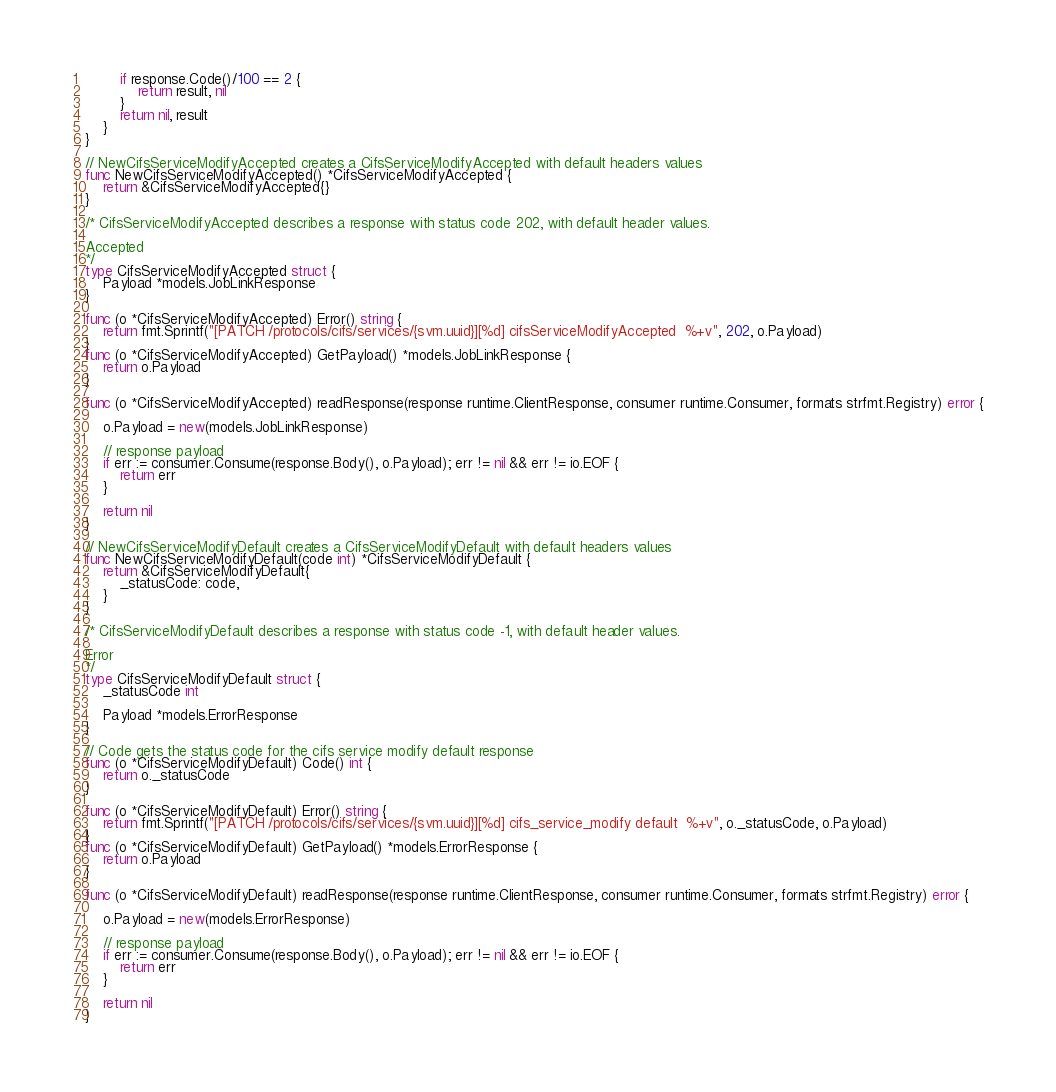Convert code to text. <code><loc_0><loc_0><loc_500><loc_500><_Go_>		if response.Code()/100 == 2 {
			return result, nil
		}
		return nil, result
	}
}

// NewCifsServiceModifyAccepted creates a CifsServiceModifyAccepted with default headers values
func NewCifsServiceModifyAccepted() *CifsServiceModifyAccepted {
	return &CifsServiceModifyAccepted{}
}

/* CifsServiceModifyAccepted describes a response with status code 202, with default header values.

Accepted
*/
type CifsServiceModifyAccepted struct {
	Payload *models.JobLinkResponse
}

func (o *CifsServiceModifyAccepted) Error() string {
	return fmt.Sprintf("[PATCH /protocols/cifs/services/{svm.uuid}][%d] cifsServiceModifyAccepted  %+v", 202, o.Payload)
}
func (o *CifsServiceModifyAccepted) GetPayload() *models.JobLinkResponse {
	return o.Payload
}

func (o *CifsServiceModifyAccepted) readResponse(response runtime.ClientResponse, consumer runtime.Consumer, formats strfmt.Registry) error {

	o.Payload = new(models.JobLinkResponse)

	// response payload
	if err := consumer.Consume(response.Body(), o.Payload); err != nil && err != io.EOF {
		return err
	}

	return nil
}

// NewCifsServiceModifyDefault creates a CifsServiceModifyDefault with default headers values
func NewCifsServiceModifyDefault(code int) *CifsServiceModifyDefault {
	return &CifsServiceModifyDefault{
		_statusCode: code,
	}
}

/* CifsServiceModifyDefault describes a response with status code -1, with default header values.

Error
*/
type CifsServiceModifyDefault struct {
	_statusCode int

	Payload *models.ErrorResponse
}

// Code gets the status code for the cifs service modify default response
func (o *CifsServiceModifyDefault) Code() int {
	return o._statusCode
}

func (o *CifsServiceModifyDefault) Error() string {
	return fmt.Sprintf("[PATCH /protocols/cifs/services/{svm.uuid}][%d] cifs_service_modify default  %+v", o._statusCode, o.Payload)
}
func (o *CifsServiceModifyDefault) GetPayload() *models.ErrorResponse {
	return o.Payload
}

func (o *CifsServiceModifyDefault) readResponse(response runtime.ClientResponse, consumer runtime.Consumer, formats strfmt.Registry) error {

	o.Payload = new(models.ErrorResponse)

	// response payload
	if err := consumer.Consume(response.Body(), o.Payload); err != nil && err != io.EOF {
		return err
	}

	return nil
}
</code> 